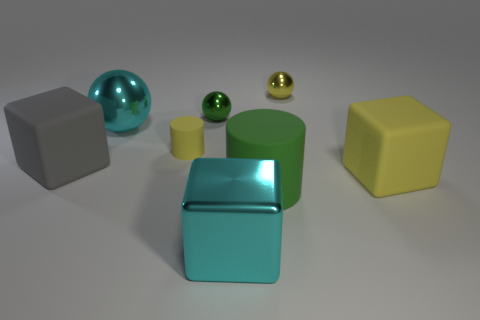Is the number of large cyan spheres that are behind the small yellow metallic thing greater than the number of big green rubber blocks?
Offer a very short reply. No. There is a large block that is to the left of the small yellow cylinder; what number of big matte blocks are right of it?
Your response must be concise. 1. Are the big cyan object that is in front of the green rubber cylinder and the green cylinder that is to the right of the large cyan block made of the same material?
Provide a short and direct response. No. There is a large cube that is the same color as the small rubber cylinder; what is its material?
Ensure brevity in your answer.  Rubber. How many big cyan things are the same shape as the big gray object?
Provide a succinct answer. 1. Is the cyan ball made of the same material as the large thing that is on the left side of the big cyan metal sphere?
Offer a terse response. No. There is a gray thing that is the same size as the cyan block; what is it made of?
Provide a succinct answer. Rubber. Are there any yellow shiny spheres that have the same size as the green metallic ball?
Your response must be concise. Yes. There is a yellow matte thing that is the same size as the yellow ball; what shape is it?
Give a very brief answer. Cylinder. How many other things are the same color as the small cylinder?
Your answer should be very brief. 2. 